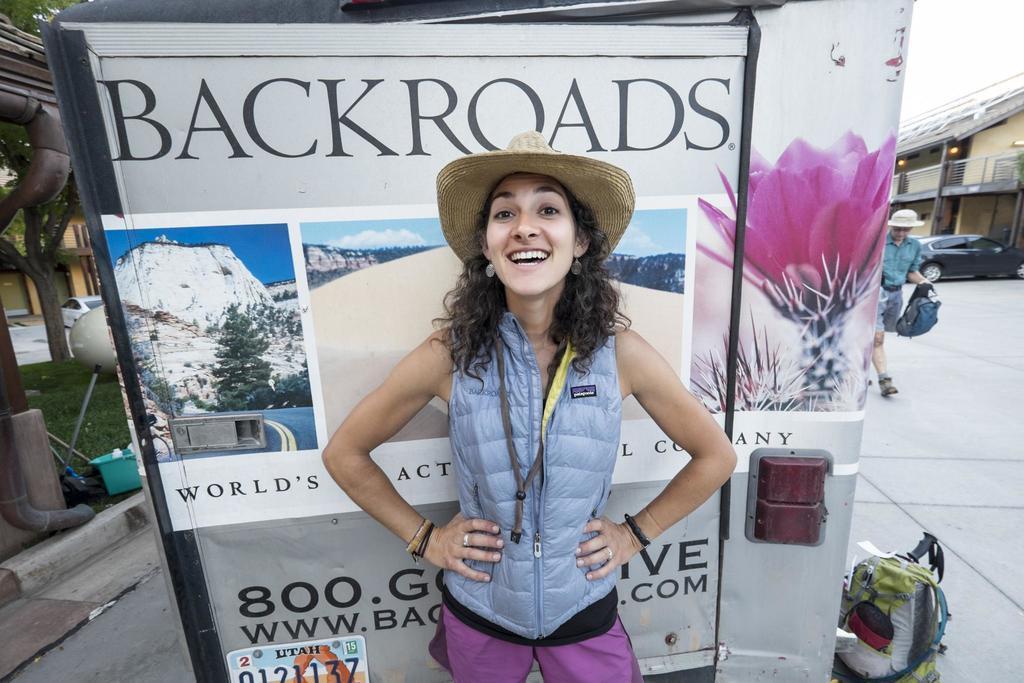Could you give a brief overview of what you see in this image? In this image, we can see a woman standing, she is wearing a hat, there is a poster and we can see a bag on the floor, in the background, we can see a person walking and we can see a building, at the top there is a sky. 